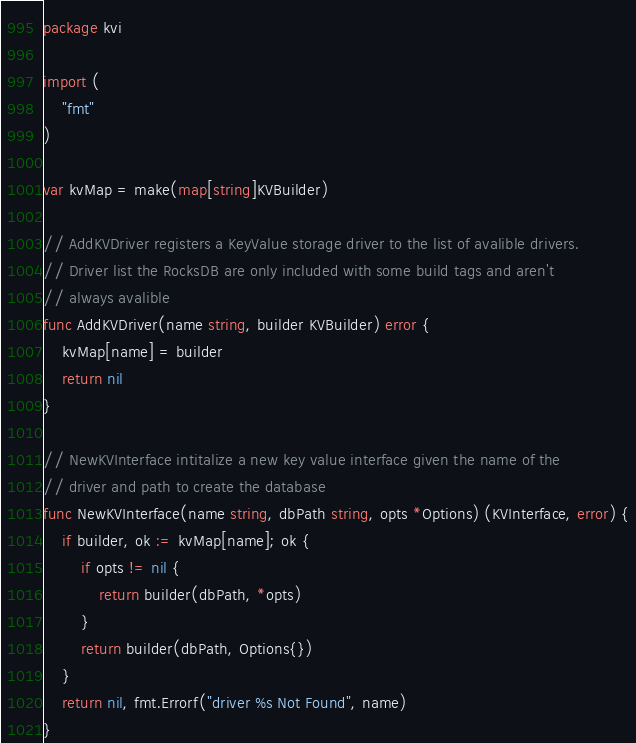<code> <loc_0><loc_0><loc_500><loc_500><_Go_>package kvi

import (
	"fmt"
)

var kvMap = make(map[string]KVBuilder)

// AddKVDriver registers a KeyValue storage driver to the list of avalible drivers.
// Driver list the RocksDB are only included with some build tags and aren't
// always avalible
func AddKVDriver(name string, builder KVBuilder) error {
	kvMap[name] = builder
	return nil
}

// NewKVInterface intitalize a new key value interface given the name of the
// driver and path to create the database
func NewKVInterface(name string, dbPath string, opts *Options) (KVInterface, error) {
	if builder, ok := kvMap[name]; ok {
		if opts != nil {
			return builder(dbPath, *opts)
		}
		return builder(dbPath, Options{})
	}
	return nil, fmt.Errorf("driver %s Not Found", name)
}
</code> 